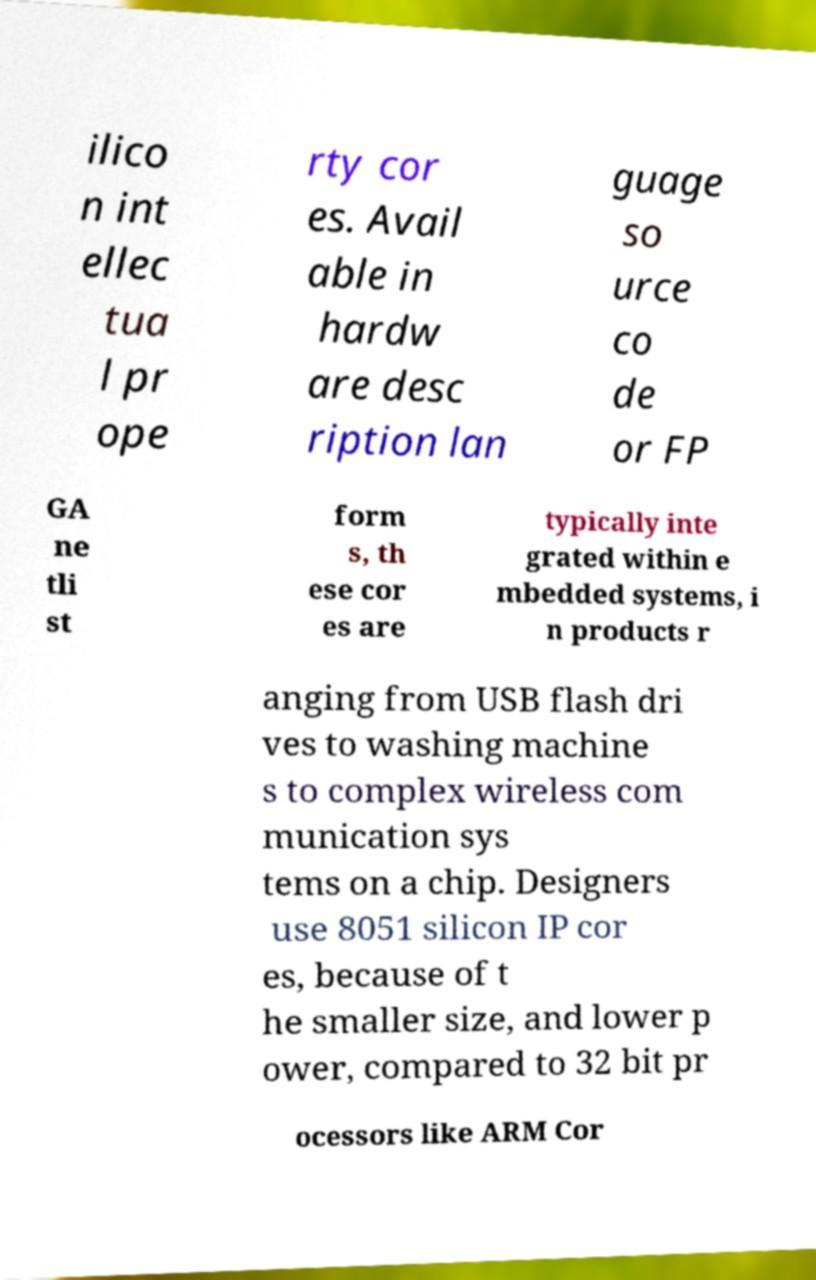Please read and relay the text visible in this image. What does it say? ilico n int ellec tua l pr ope rty cor es. Avail able in hardw are desc ription lan guage so urce co de or FP GA ne tli st form s, th ese cor es are typically inte grated within e mbedded systems, i n products r anging from USB flash dri ves to washing machine s to complex wireless com munication sys tems on a chip. Designers use 8051 silicon IP cor es, because of t he smaller size, and lower p ower, compared to 32 bit pr ocessors like ARM Cor 